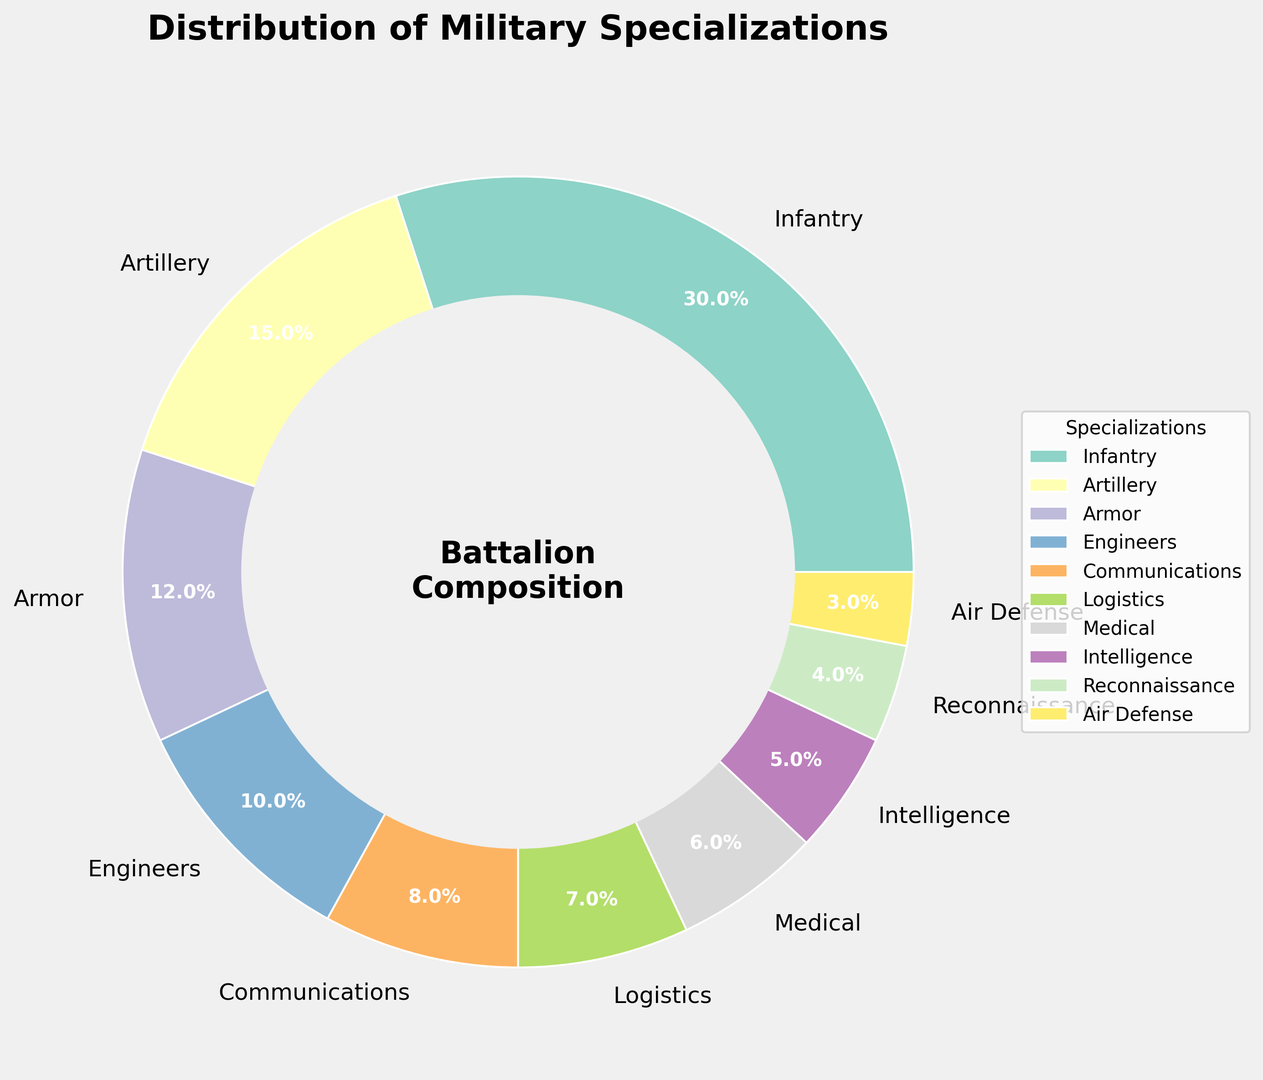What percentage of the battalion is specialized in Infantry? The figure shows that Infantry is the largest segment in the ring chart, and the label indicates it as 30%.
Answer: 30% Which specialization has a smaller percentage: Intelligence or Communications? The figure shows that Intelligence is 5% and Communications is 8%. Since 5% is less than 8%, Intelligence has a smaller percentage.
Answer: Intelligence What is the combined percentage of Armor, Engineers, and Medical specializations? The percentages for Armor, Engineers, and Medical are 12%, 10%, and 6% respectively. Adding them up: 12 + 10 + 6 = 28%.
Answer: 28% Is the percentage of Logistics specialization greater than Air Defense and Reconnaissance combined? Logistics has a percentage of 7%. Air Defense and Reconnaissance together are 3% and 4%, respectively, adding up to 3 + 4 = 7%. Since 7% is not greater than 7%, Logistics is not greater than their combination.
Answer: No How many specializations make up more than 10% of the battalion? The figure labels show the percentages. Only Infantry (30%), Artillery (15%), and Armor (12%) are above 10%. Counting them gives 3.
Answer: 3 Which specialization occupies the smallest segment in the ring chart? The smallest segment in the ring chart is labeled Air Defense with 3%.
Answer: Air Defense What is the difference in percentage between Infantry and Medical? Infantry is 30% and Medical is 6%. The difference is 30 - 6 = 24%.
Answer: 24% What is the average percentage of Communications, Logistics, and Reconnaissance specializations? Their percentages are 8%, 7%, and 4% respectively. The sum is 8 + 7 + 4 = 19%. The average is 19/3 ≈ 6.33%.
Answer: 6.33% Which color represents the Infantry specialization in the ring chart? The color representing each specialization is shown in the figure. Infantry is represented by the first segment/color.
Answer: Answer depends on the figure (typically provided as visual info) How much more percentage is Artillery compared to Air Defense? Artillery is 15% and Air Defense is 3%. The difference is 15 - 3 = 12%.
Answer: 12% 